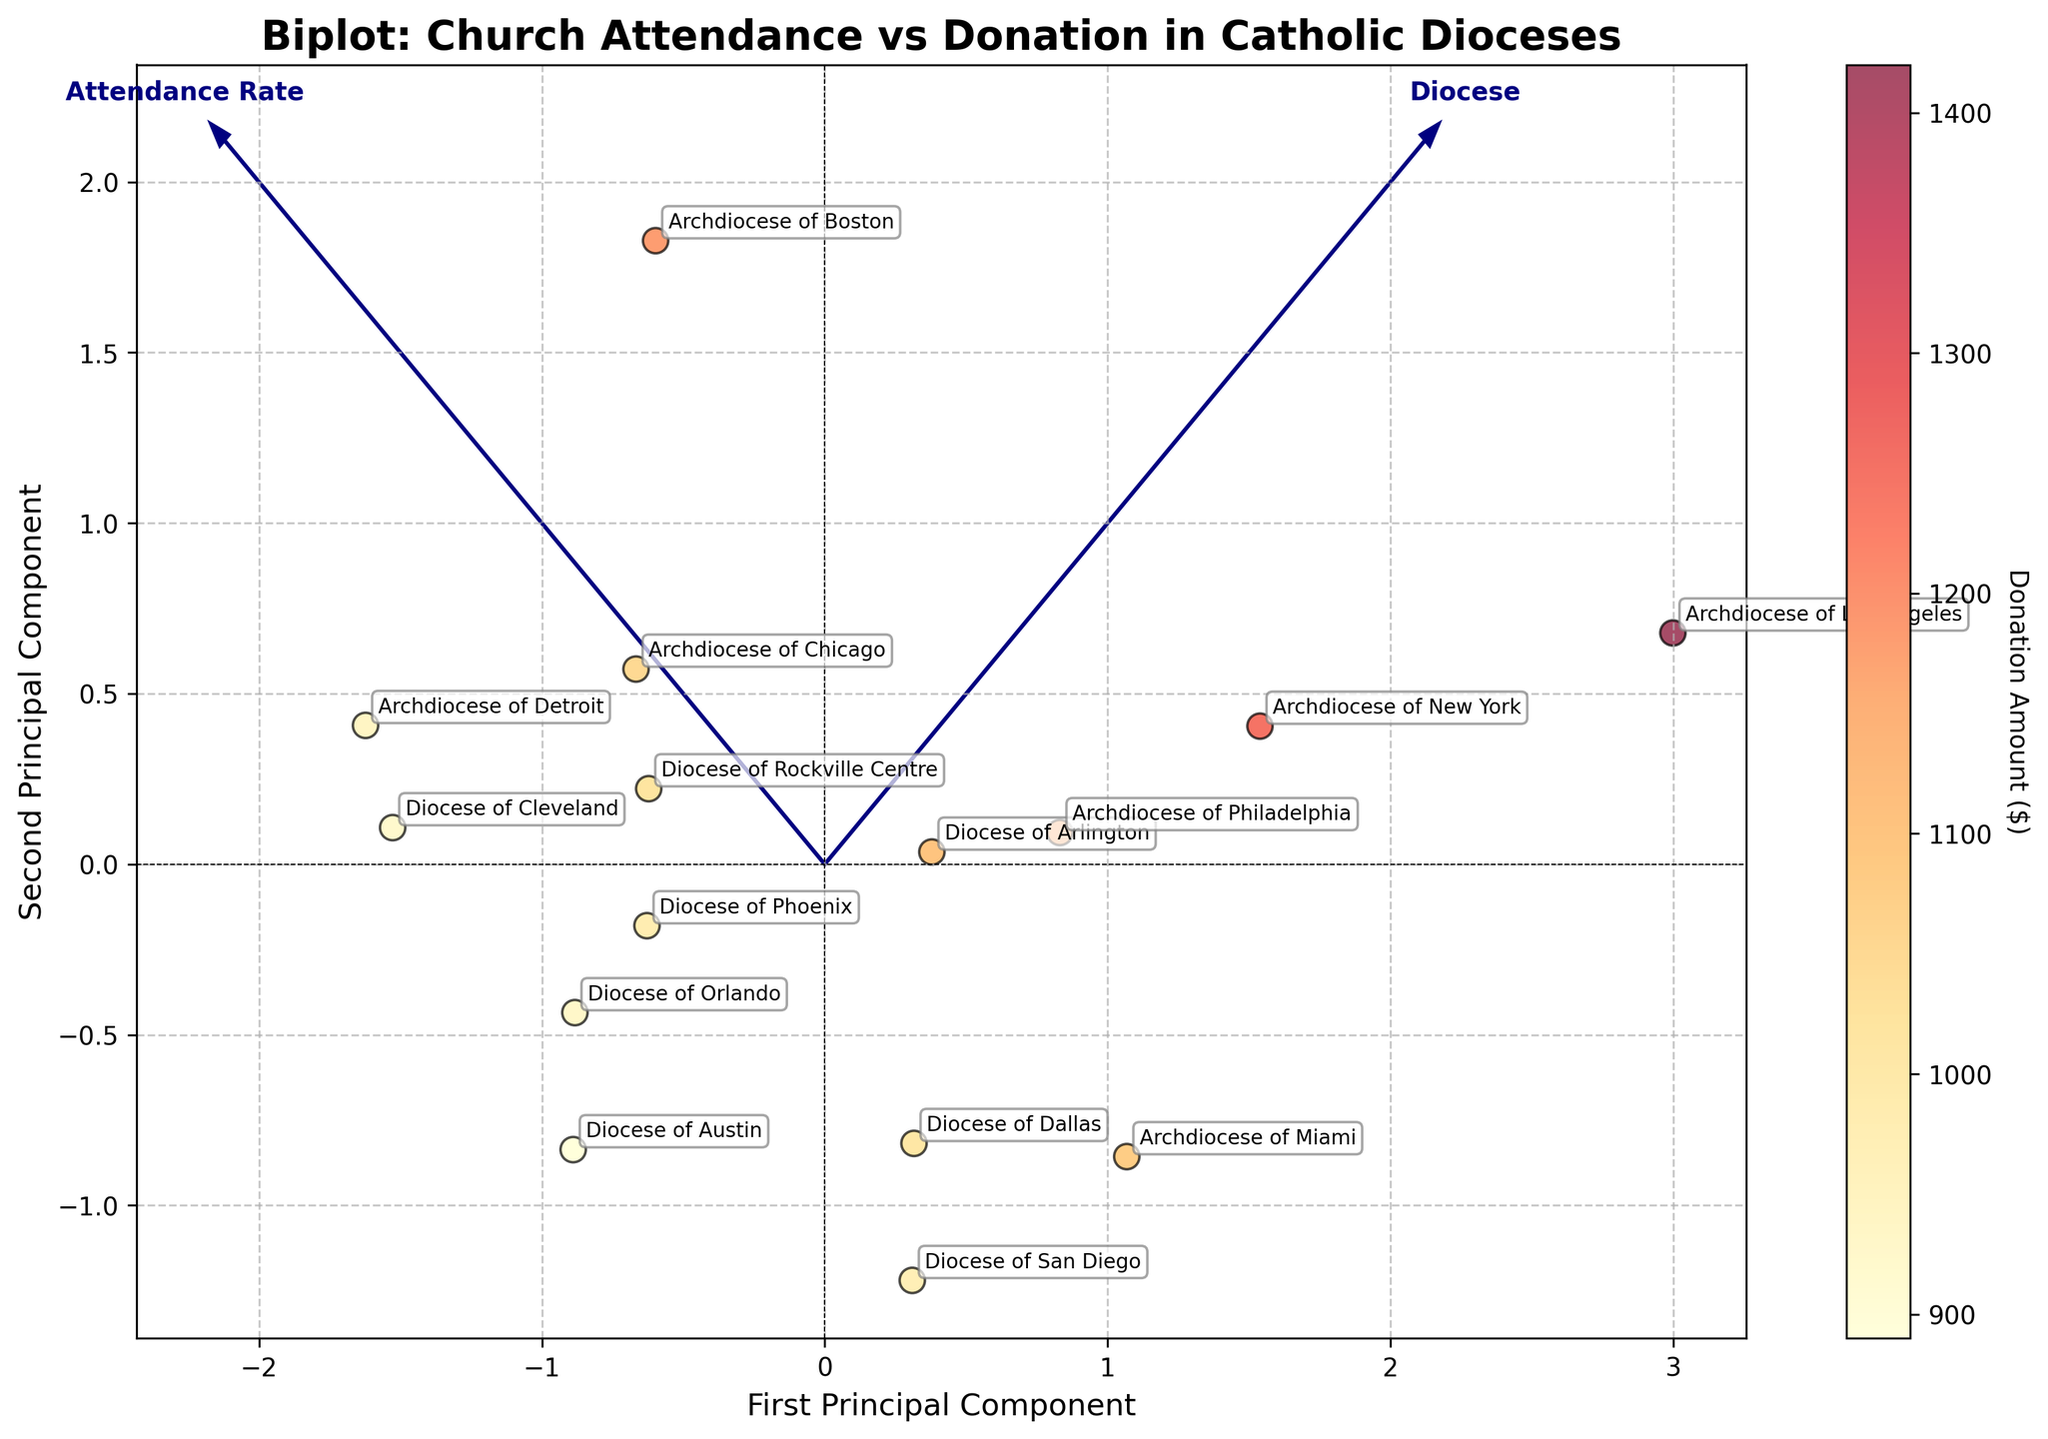How many data points are there in the plot? Look at the number of points (dioceses) marked on the plot. Each point represents one diocese.
Answer: 14 Which diocese has the highest attendance rate? Identify the diocese with the highest position along the 'Attendance Rate' axis (or the longest projection in the positive direction if regarding the arrows).
Answer: Archdiocese of Los Angeles Which diocese has the lowest donation amount? Look for the point with the lightest color, as the colormap represents donation amounts where lighter colors indicate lower amounts.
Answer: Diocese of Austin Which diocese has a higher attendance rate, Diocese of Arlington, or Diocese of Rockville Centre? Examine the positioning of both dioceses along the 'Attendance Rate' axis. The higher position indicates a higher attendance rate.
Answer: Diocese of Arlington How do the Archdiocese of Boston and the Archdiocese of Miami compare in terms of donation amounts? Compare the color intensity of both points; darker colors indicate higher donations.
Answer: Archdiocese of Boston has higher donations than Archdiocese of Miami What do the arrows in the figure represent? The arrows (feature vectors) represent the directions of maximum variance in the data; they indicate the contribution of each feature toward the principal components.
Answer: Directions of maximum variance Which dioceses fall closest to the origin of the principal components? Identify the points nearest to (0,0) in the plot, indicating average values for both attendance and donation.
Answer: Diocese of Phoenix and Diocese of San Diego Is there a relationship between attendance rate and donation amount? Look for a pattern in how the points are distributed in the plot; points shifting consistently in one direction (or color gradients) could indicate a relationship.
Answer: No strong evident correlation Which has a greater variance, attendance rates or donation amounts? Compare the lengths of the arrows (feature vectors); longer arrows indicate higher variance.
Answer: Donation amounts What does the first principal component primarily represent? Observe which of the original variables ('Attendance Rate' or 'Donation Amount') has a larger projection along the first principal component (x-axis).
Answer: Donation Amount 